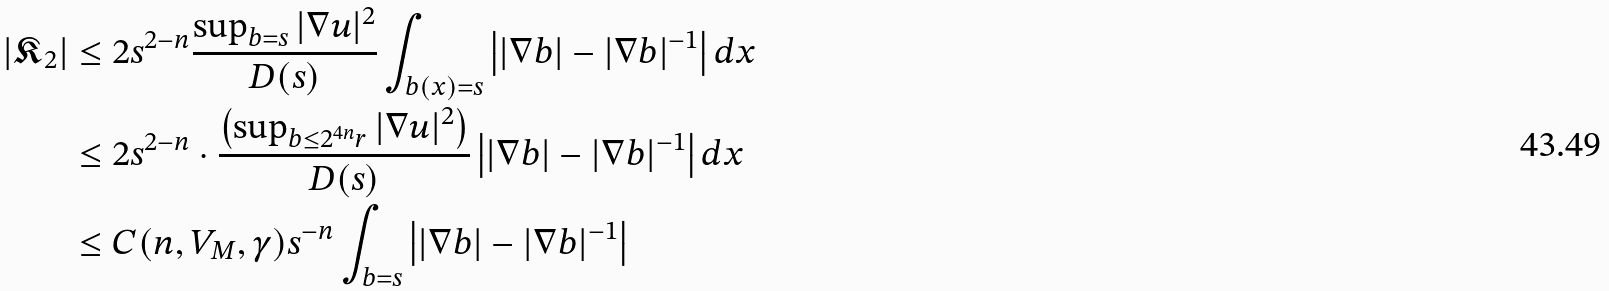<formula> <loc_0><loc_0><loc_500><loc_500>| \mathfrak { K } _ { 2 } | & \leq 2 s ^ { 2 - n } \frac { \sup _ { b = s } | \nabla u | ^ { 2 } } { D ( s ) } \int _ { b ( x ) = s } \left | | \nabla b | - | \nabla b | ^ { - 1 } \right | d x \\ & \leq 2 s ^ { 2 - n } \cdot \frac { \left ( \sup _ { b \leq 2 ^ { 4 n } r } | \nabla u | ^ { 2 } \right ) } { D ( s ) } \left | | \nabla b | - | \nabla b | ^ { - 1 } \right | d x \\ & \leq C ( n , V _ { M } , \gamma ) s ^ { - n } \int _ { b = s } \left | | \nabla b | - | \nabla b | ^ { - 1 } \right |</formula> 